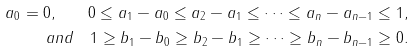<formula> <loc_0><loc_0><loc_500><loc_500>a _ { 0 } = 0 , \quad 0 \leq a _ { 1 } - a _ { 0 } \leq a _ { 2 } - a _ { 1 } \leq \dots \leq a _ { n } - a _ { n - 1 } \leq 1 , \\ a n d \quad 1 \geq b _ { 1 } - b _ { 0 } \geq b _ { 2 } - b _ { 1 } \geq \dots \geq b _ { n } - b _ { n - 1 } \geq 0 .</formula> 